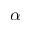Convert formula to latex. <formula><loc_0><loc_0><loc_500><loc_500>\alpha</formula> 